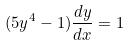Convert formula to latex. <formula><loc_0><loc_0><loc_500><loc_500>( 5 y ^ { 4 } - 1 ) \frac { d y } { d x } = 1</formula> 